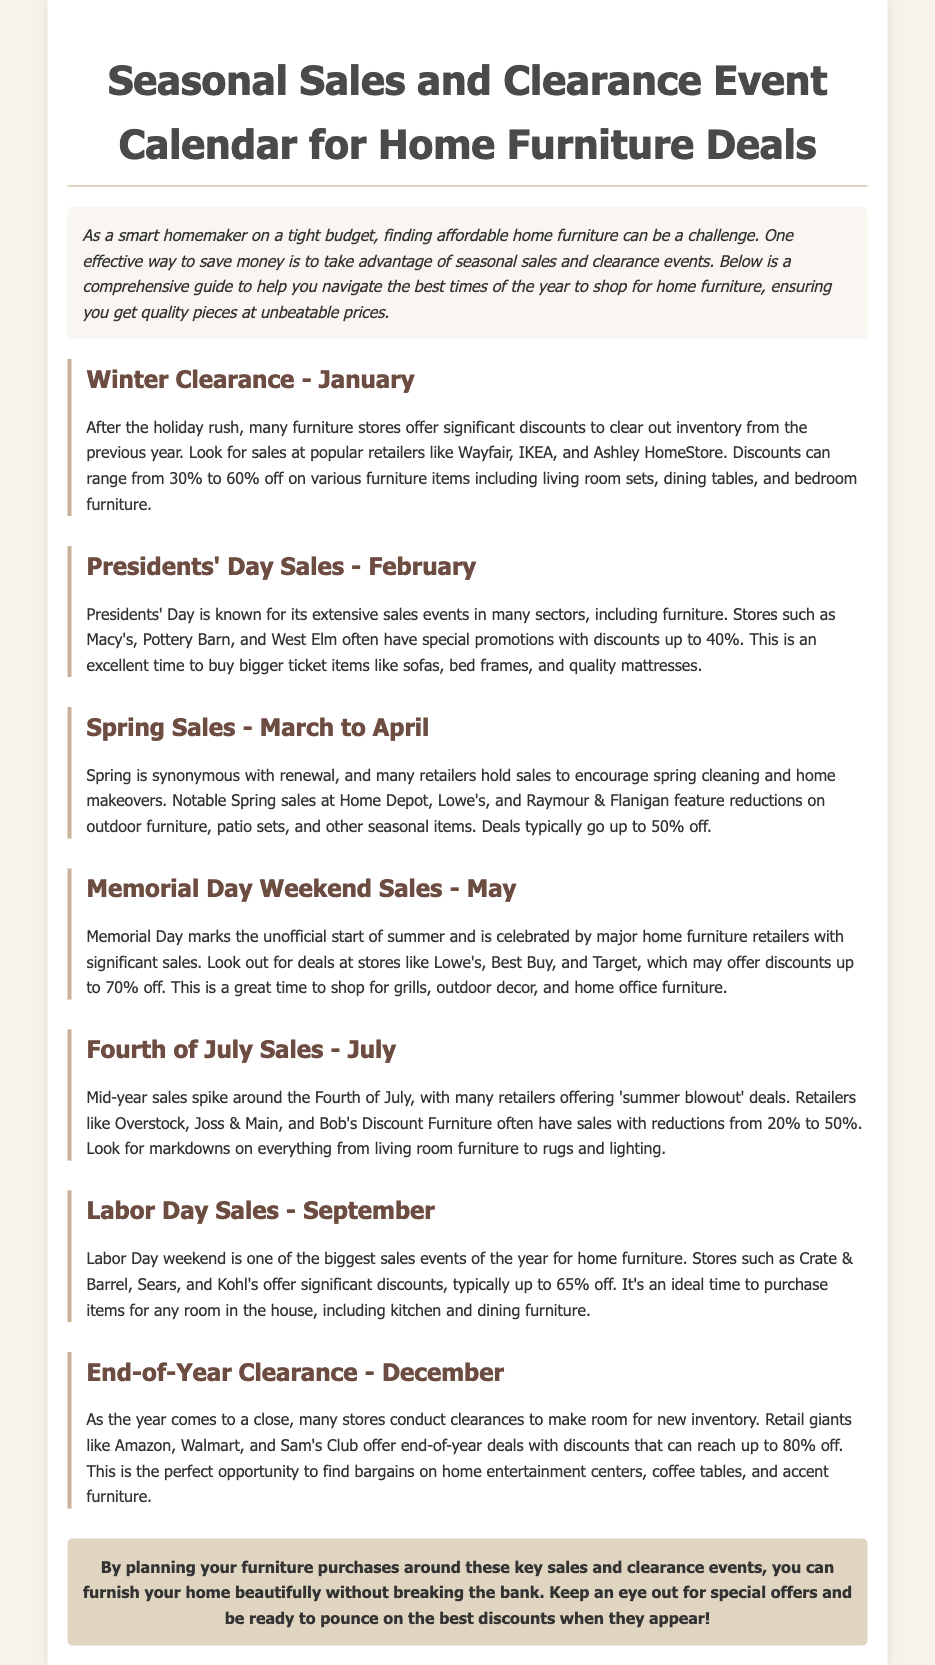What month does the Winter Clearance occur? The document states that Winter Clearance happens in January.
Answer: January What is the maximum discount typically seen during Presidents' Day Sales? According to the document, discounts during Presidents' Day Sales can go up to 40%.
Answer: 40% Which retailers are mentioned for Memorial Day Weekend Sales? The document lists Lowe's, Best Buy, and Target as retailers for Memorial Day Weekend Sales.
Answer: Lowe's, Best Buy, Target How much can you potentially save during the End-of-Year Clearance? The document indicates that discounts during the End-of-Year Clearance can reach up to 80%.
Answer: 80% What type of furniture is highlighted for significant discounts during Labor Day Sales? The document mentions that Labor Day Sales are ideal for purchasing kitchen and dining furniture.
Answer: Kitchen and dining furniture Which seasonal sales occur in March and April? The document states that Spring Sales occur during March to April.
Answer: Spring Sales What is one benefit of shopping during these sales according to the document? The document suggests that shopping during these sales helps furnish your home beautifully without breaking the bank.
Answer: Save money How do seasonal sales events help smart homemakers? The document explains that they ensure quality pieces at unbeatable prices, catering to budget-conscious shoppers.
Answer: Affordable quality furniture 